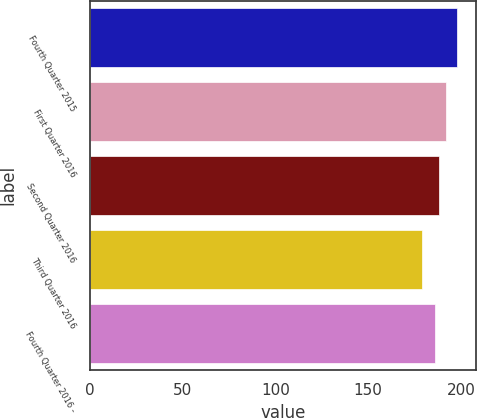<chart> <loc_0><loc_0><loc_500><loc_500><bar_chart><fcel>Fourth Quarter 2015<fcel>First Quarter 2016<fcel>Second Quarter 2016<fcel>Third Quarter 2016<fcel>Fourth Quarter 2016 -<nl><fcel>198<fcel>192<fcel>187.9<fcel>179<fcel>186<nl></chart> 